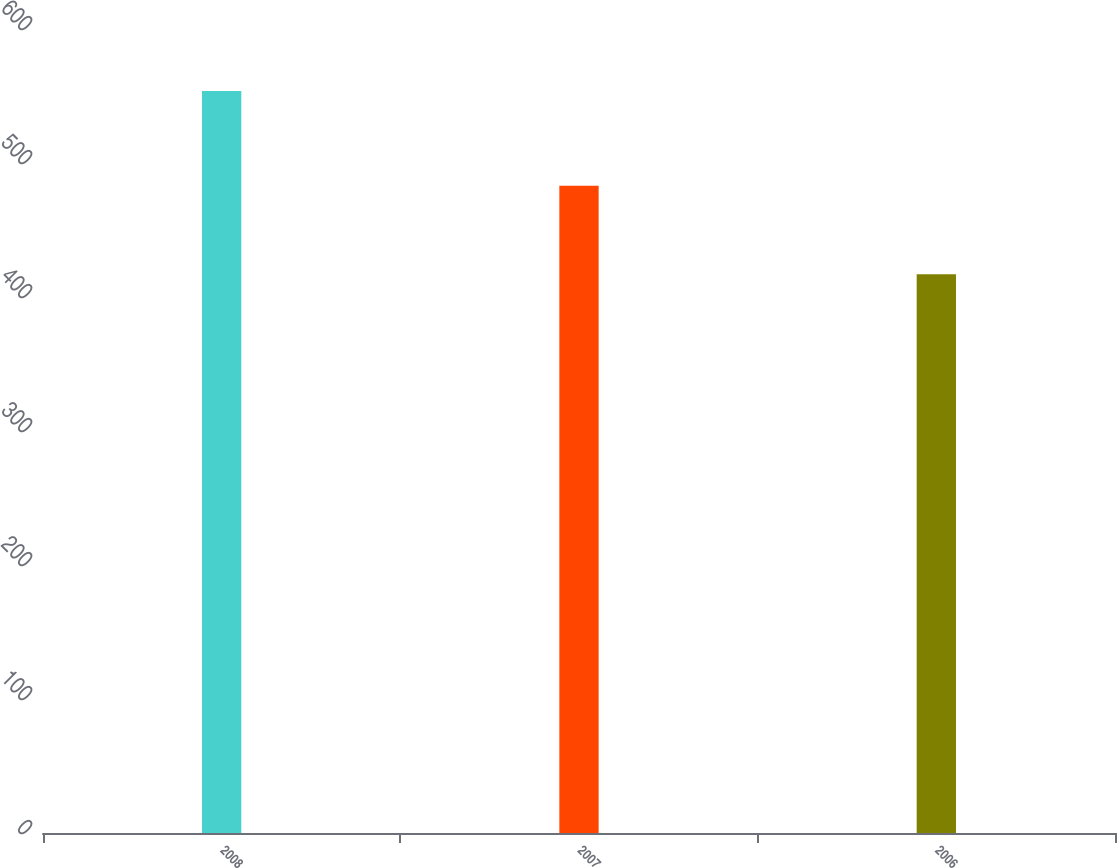Convert chart to OTSL. <chart><loc_0><loc_0><loc_500><loc_500><bar_chart><fcel>2008<fcel>2007<fcel>2006<nl><fcel>553.7<fcel>483<fcel>417<nl></chart> 